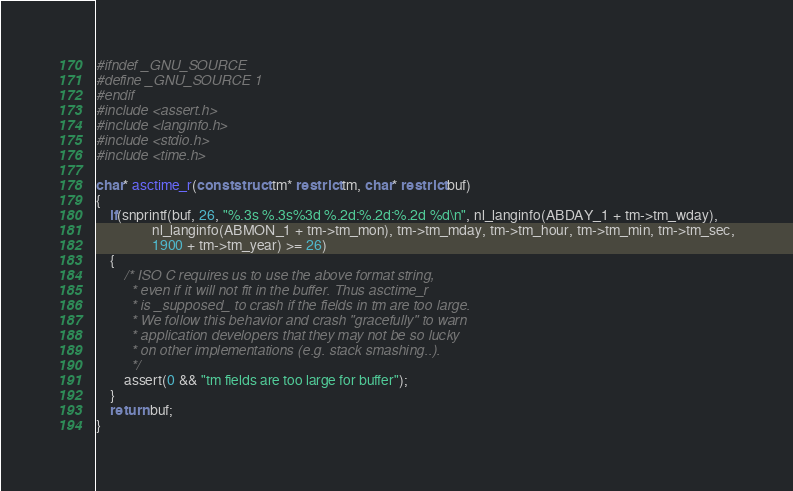<code> <loc_0><loc_0><loc_500><loc_500><_C_>#ifndef _GNU_SOURCE
#define _GNU_SOURCE 1
#endif
#include <assert.h>
#include <langinfo.h>
#include <stdio.h>
#include <time.h>

char* asctime_r(const struct tm* restrict tm, char* restrict buf)
{
	if(snprintf(buf, 26, "%.3s %.3s%3d %.2d:%.2d:%.2d %d\n", nl_langinfo(ABDAY_1 + tm->tm_wday),
				nl_langinfo(ABMON_1 + tm->tm_mon), tm->tm_mday, tm->tm_hour, tm->tm_min, tm->tm_sec,
				1900 + tm->tm_year) >= 26)
	{
		/* ISO C requires us to use the above format string,
		 * even if it will not fit in the buffer. Thus asctime_r
		 * is _supposed_ to crash if the fields in tm are too large.
		 * We follow this behavior and crash "gracefully" to warn
		 * application developers that they may not be so lucky
		 * on other implementations (e.g. stack smashing..).
		 */
		assert(0 && "tm fields are too large for buffer");
	}
	return buf;
}
</code> 